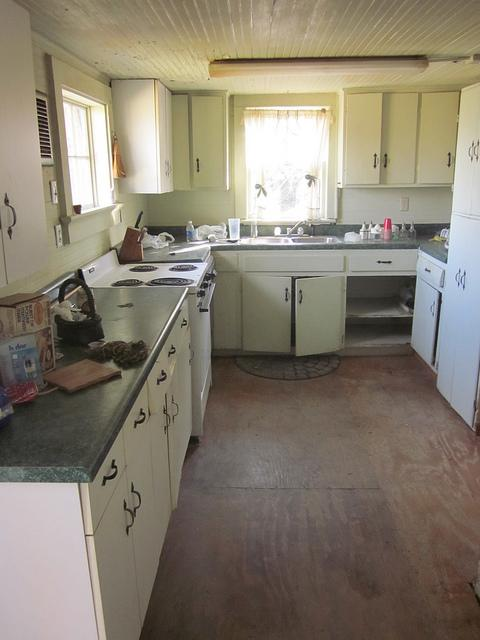What is the black and white object to the left of the window? Please explain your reasoning. vent. The object on the wall is an opening for heat or air conditioning to fill the room. 